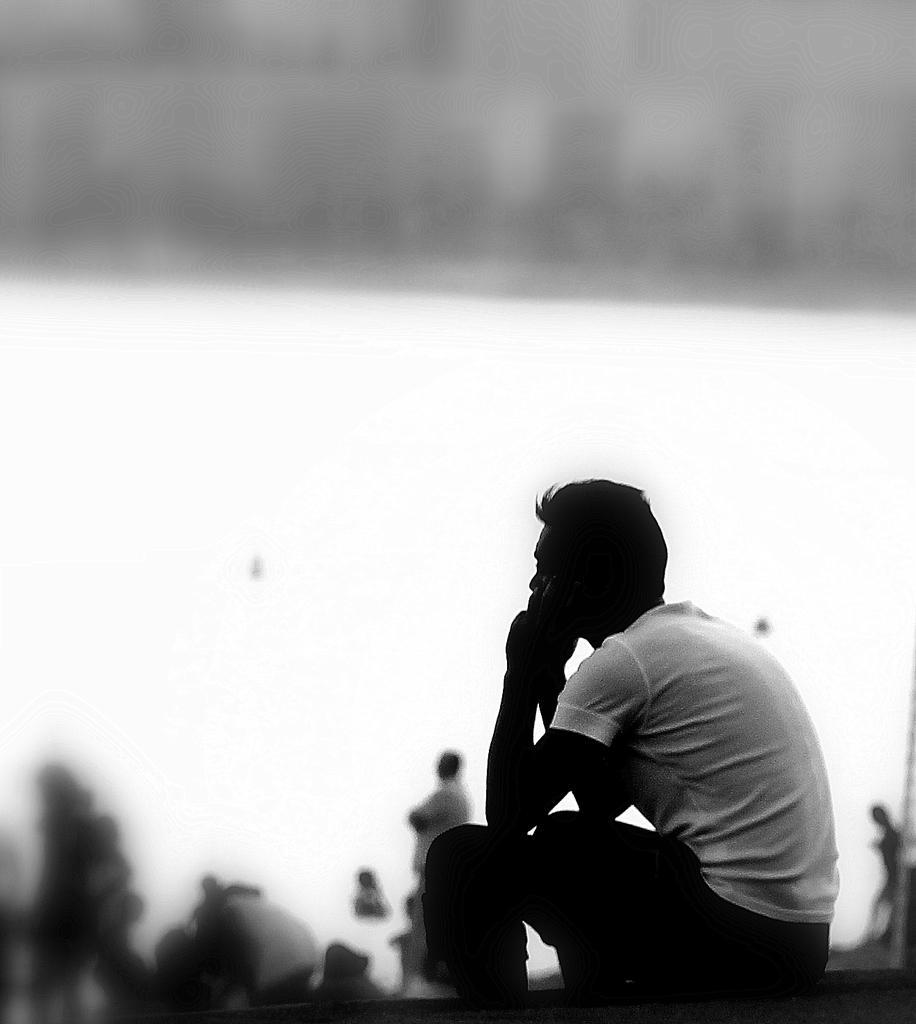Describe this image in one or two sentences. This is a black and white picture. Here we can see a person is sitting on a platform. There is a blur background and we can see people. 